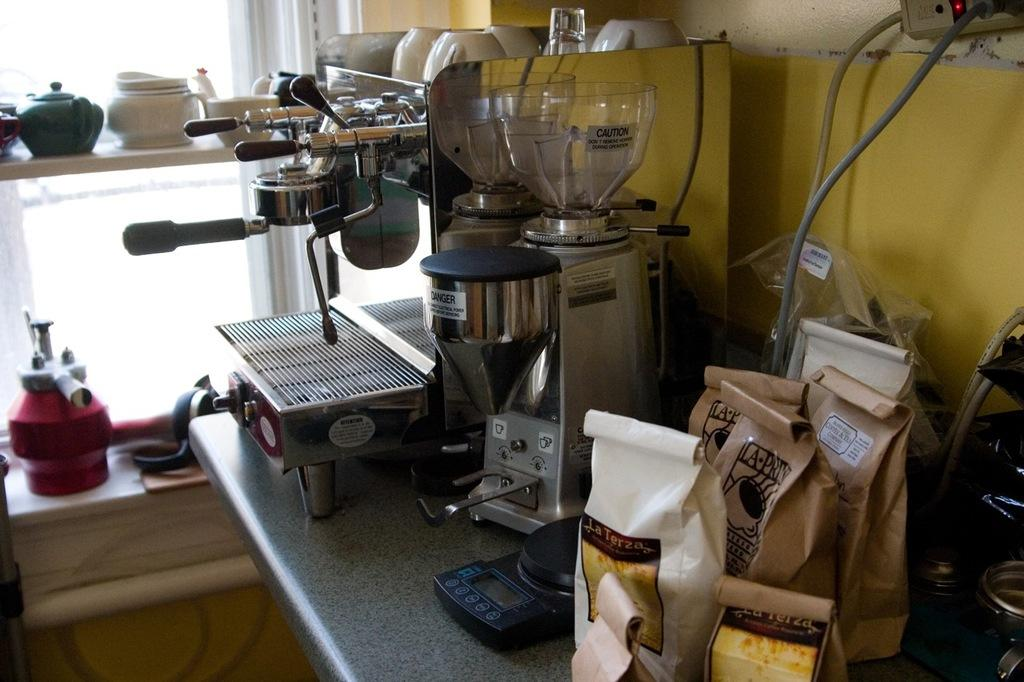<image>
Render a clear and concise summary of the photo. Several bags of La Terza coffee are on a counter next to a machine. 